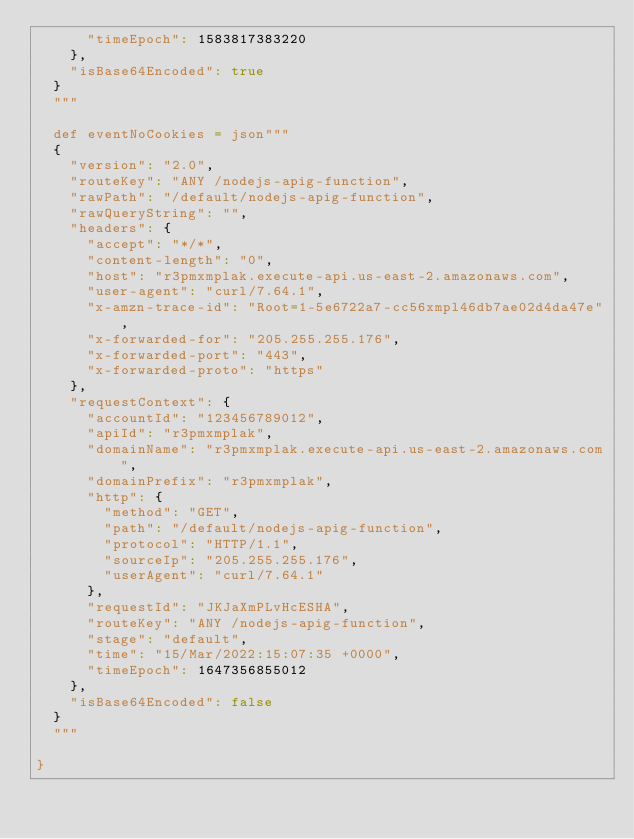<code> <loc_0><loc_0><loc_500><loc_500><_Scala_>      "timeEpoch": 1583817383220
    },
    "isBase64Encoded": true
  }
  """

  def eventNoCookies = json"""
  {
    "version": "2.0",
    "routeKey": "ANY /nodejs-apig-function",
    "rawPath": "/default/nodejs-apig-function",
    "rawQueryString": "",
    "headers": {
      "accept": "*/*",
      "content-length": "0",
      "host": "r3pmxmplak.execute-api.us-east-2.amazonaws.com",
      "user-agent": "curl/7.64.1",
      "x-amzn-trace-id": "Root=1-5e6722a7-cc56xmpl46db7ae02d4da47e",
      "x-forwarded-for": "205.255.255.176",
      "x-forwarded-port": "443",
      "x-forwarded-proto": "https"
    },
    "requestContext": {
      "accountId": "123456789012",
      "apiId": "r3pmxmplak",
      "domainName": "r3pmxmplak.execute-api.us-east-2.amazonaws.com",
      "domainPrefix": "r3pmxmplak",
      "http": {
        "method": "GET",
        "path": "/default/nodejs-apig-function",
        "protocol": "HTTP/1.1",
        "sourceIp": "205.255.255.176",
        "userAgent": "curl/7.64.1"
      },
      "requestId": "JKJaXmPLvHcESHA",
      "routeKey": "ANY /nodejs-apig-function",
      "stage": "default",
      "time": "15/Mar/2022:15:07:35 +0000",
      "timeEpoch": 1647356855012
    },
    "isBase64Encoded": false
  }
  """

}
</code> 